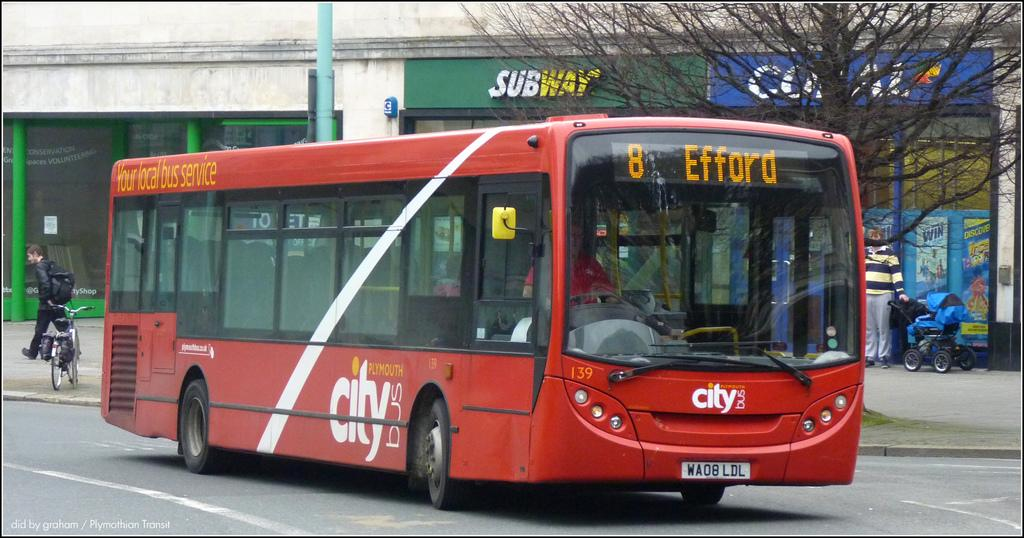<image>
Summarize the visual content of the image. A red bus with the logo for city on its front and middle section. 